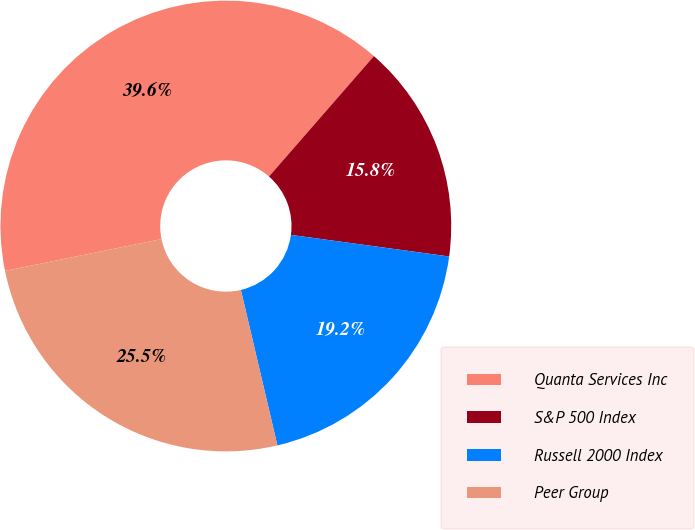<chart> <loc_0><loc_0><loc_500><loc_500><pie_chart><fcel>Quanta Services Inc<fcel>S&P 500 Index<fcel>Russell 2000 Index<fcel>Peer Group<nl><fcel>39.6%<fcel>15.75%<fcel>19.17%<fcel>25.48%<nl></chart> 